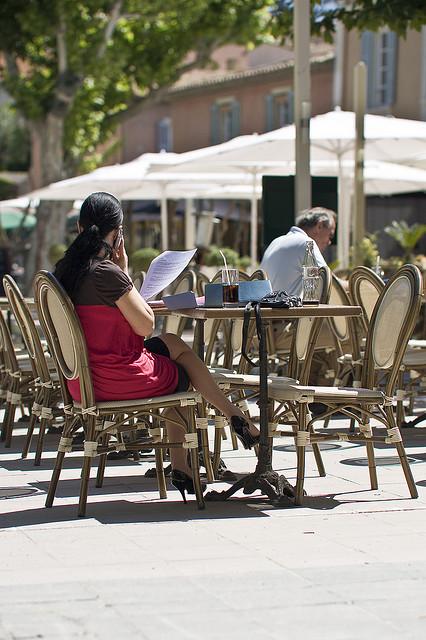IS there a man in the photo?
Give a very brief answer. Yes. How many people sit alone?
Give a very brief answer. 2. What color is the woman's dress?
Concise answer only. Red and black. 